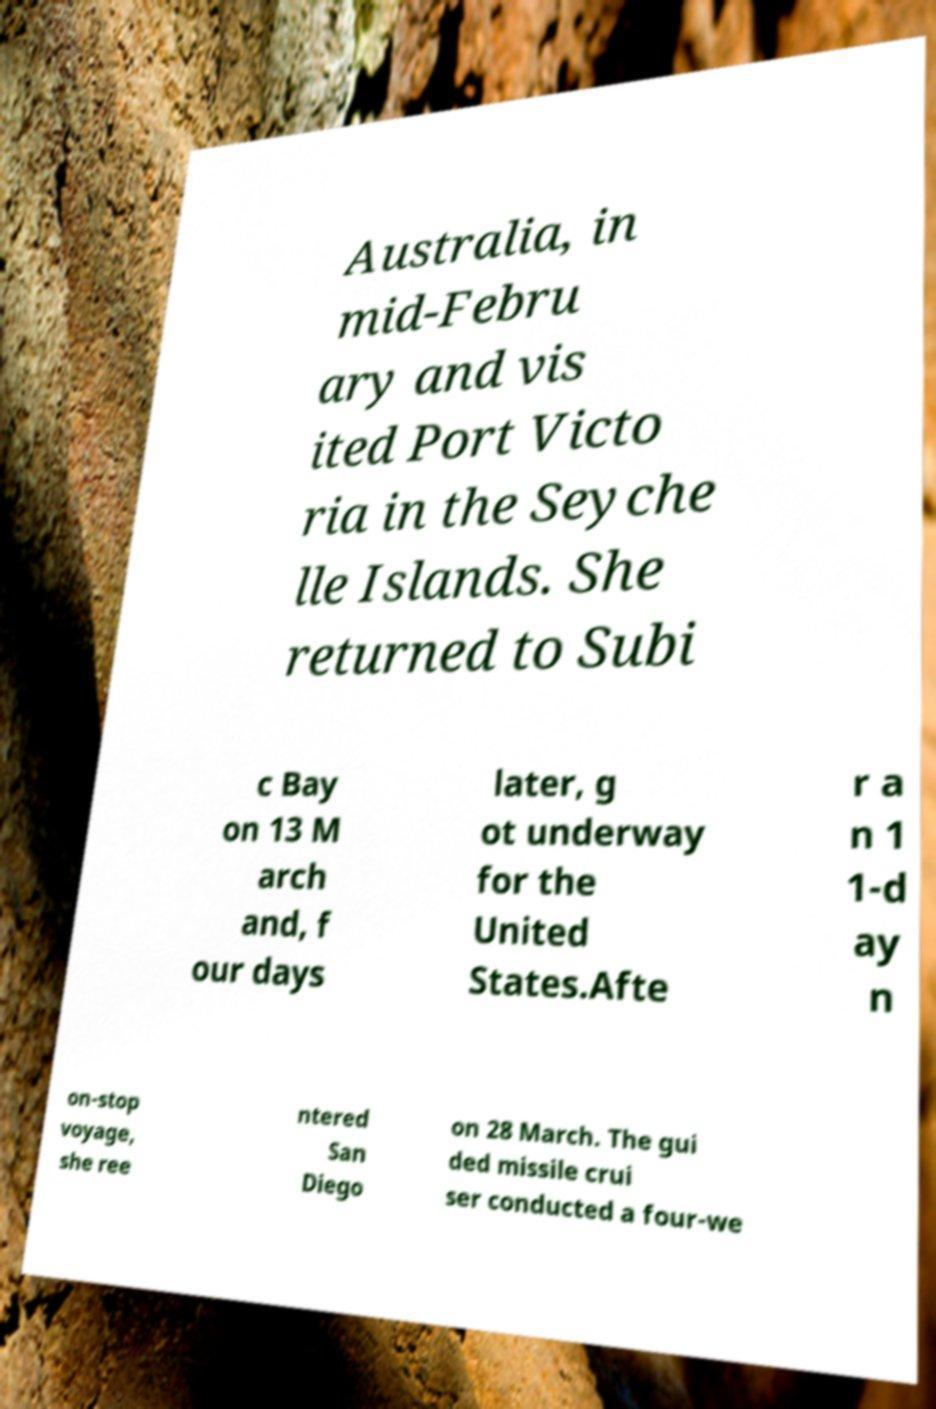Please read and relay the text visible in this image. What does it say? Australia, in mid-Febru ary and vis ited Port Victo ria in the Seyche lle Islands. She returned to Subi c Bay on 13 M arch and, f our days later, g ot underway for the United States.Afte r a n 1 1-d ay n on-stop voyage, she ree ntered San Diego on 28 March. The gui ded missile crui ser conducted a four-we 